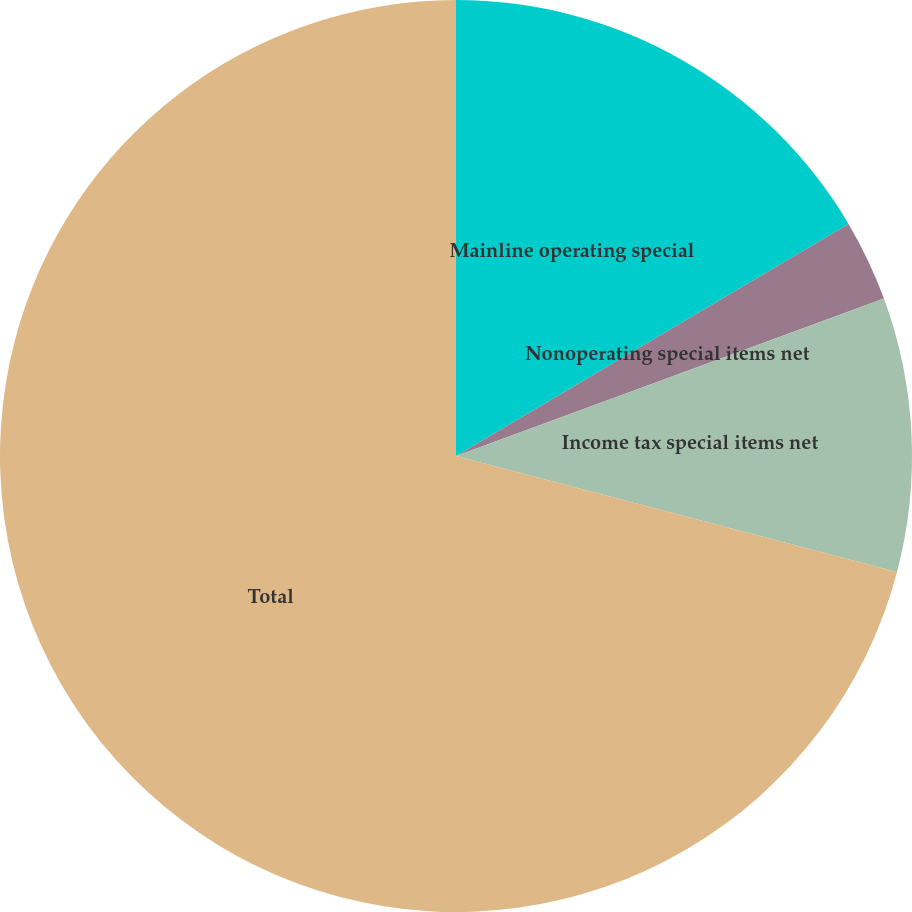Convert chart to OTSL. <chart><loc_0><loc_0><loc_500><loc_500><pie_chart><fcel>Mainline operating special<fcel>Nonoperating special items net<fcel>Income tax special items net<fcel>Total<nl><fcel>16.5%<fcel>2.89%<fcel>9.7%<fcel>70.91%<nl></chart> 